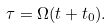Convert formula to latex. <formula><loc_0><loc_0><loc_500><loc_500>\tau = \Omega ( t + t _ { 0 } ) .</formula> 